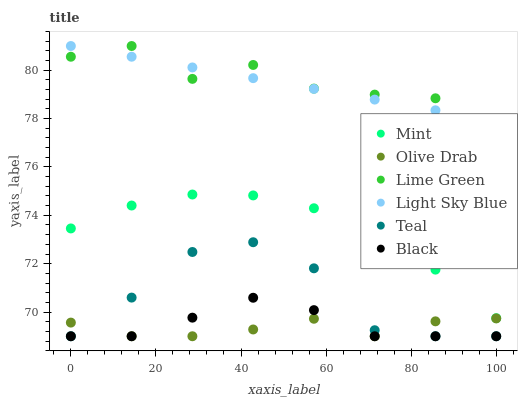Does Olive Drab have the minimum area under the curve?
Answer yes or no. Yes. Does Lime Green have the maximum area under the curve?
Answer yes or no. Yes. Does Light Sky Blue have the minimum area under the curve?
Answer yes or no. No. Does Light Sky Blue have the maximum area under the curve?
Answer yes or no. No. Is Light Sky Blue the smoothest?
Answer yes or no. Yes. Is Teal the roughest?
Answer yes or no. Yes. Is Black the smoothest?
Answer yes or no. No. Is Black the roughest?
Answer yes or no. No. Does Black have the lowest value?
Answer yes or no. Yes. Does Light Sky Blue have the lowest value?
Answer yes or no. No. Does Lime Green have the highest value?
Answer yes or no. Yes. Does Black have the highest value?
Answer yes or no. No. Is Mint less than Lime Green?
Answer yes or no. Yes. Is Mint greater than Olive Drab?
Answer yes or no. Yes. Does Black intersect Olive Drab?
Answer yes or no. Yes. Is Black less than Olive Drab?
Answer yes or no. No. Is Black greater than Olive Drab?
Answer yes or no. No. Does Mint intersect Lime Green?
Answer yes or no. No. 